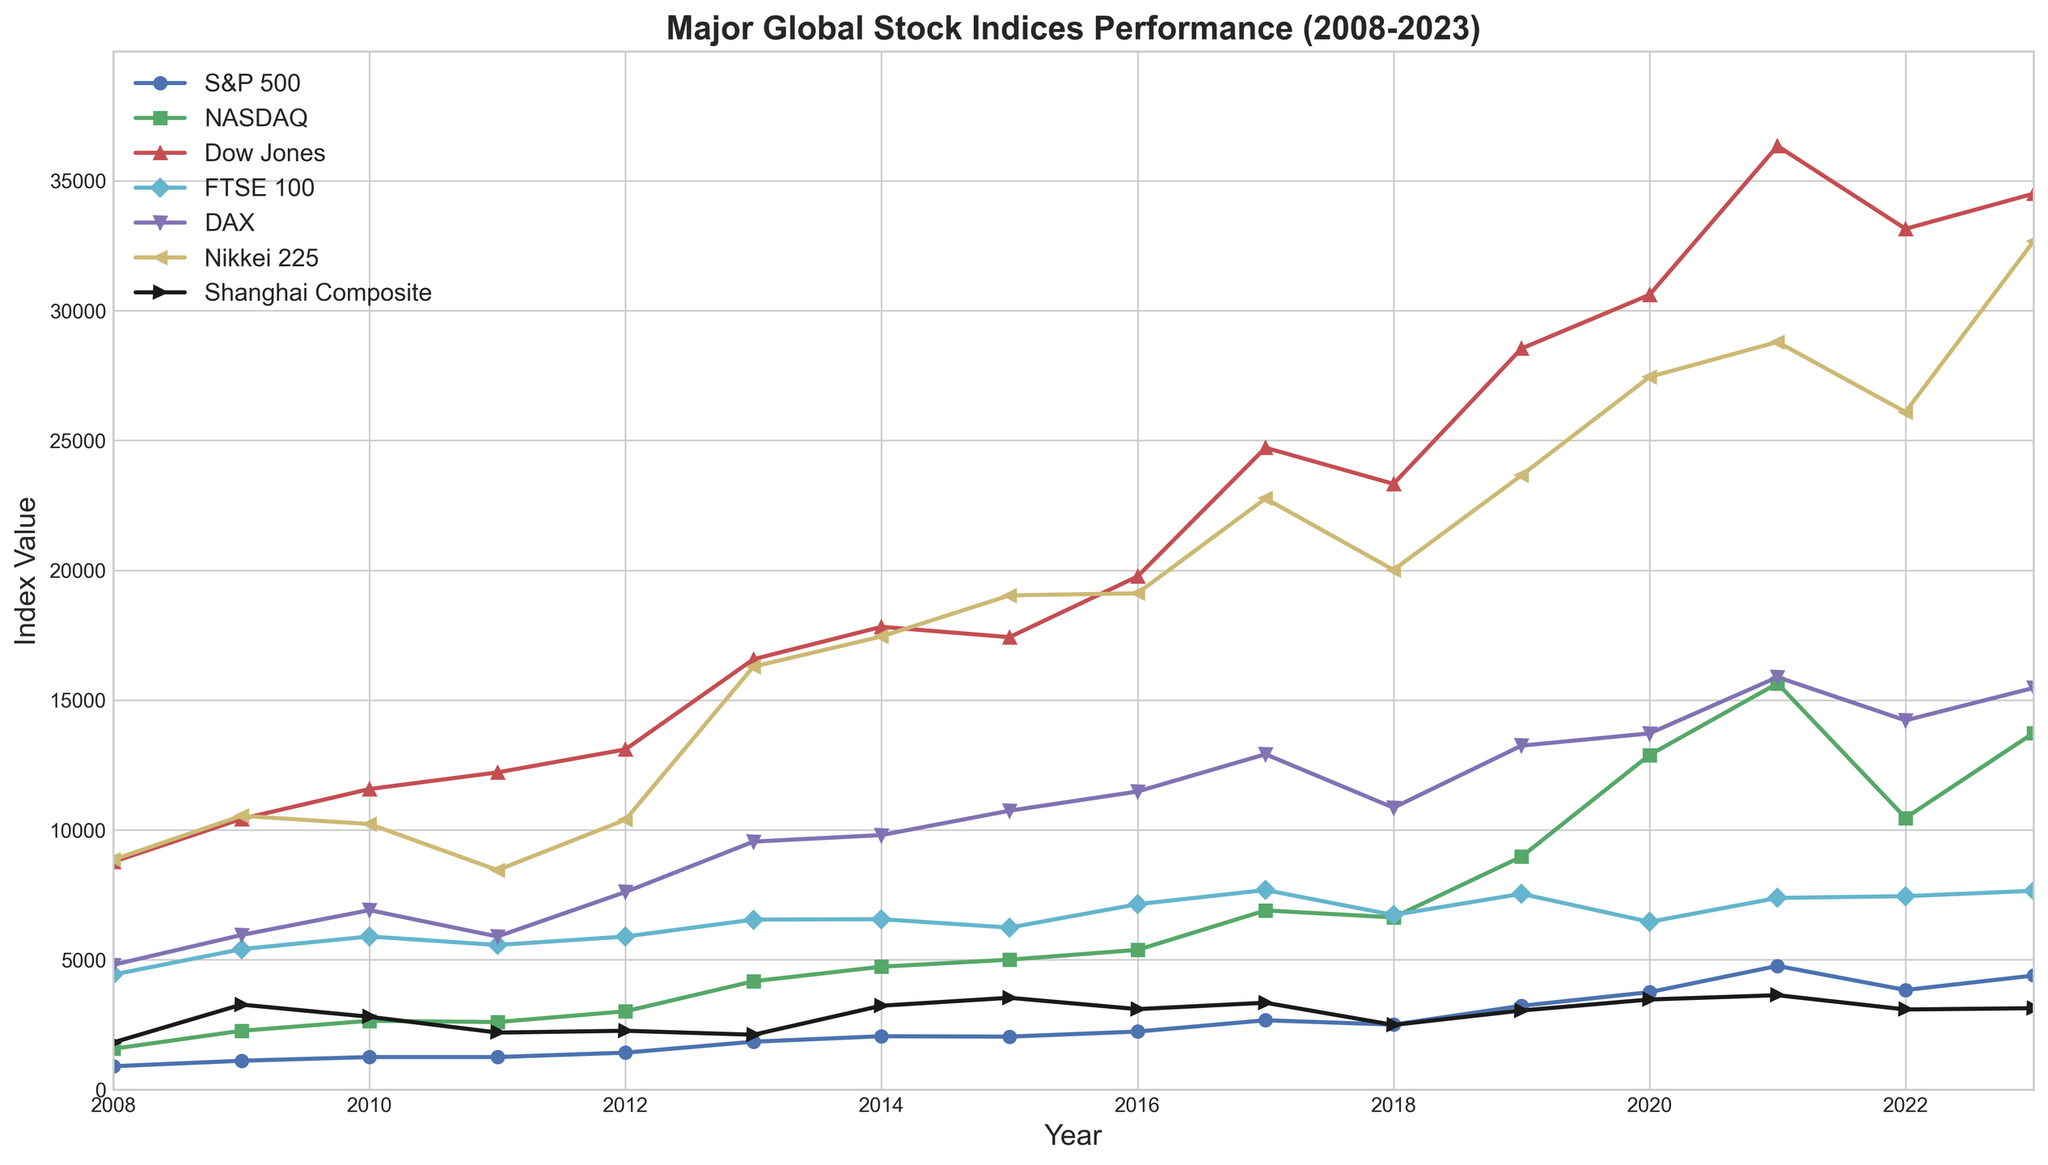What is the general trend of the S&P 500 index from 2008 to 2023? To identify the trend of the S&P 500 index, observe its values over the years. Starting from 903.25 in 2008, it increases to 4394.95 in 2023. There are fluctuations, but the overall direction is upward.
Answer: Upward Which index had the highest closing value in 2023? Look for the highest value among all indices for the year 2023. The Dow Jones has the highest closing value at 34501.11.
Answer: Dow Jones How did the NASDAQ perform in comparison to the S&P 500 in 2020? Compare the values for NASDAQ (12888.28) and S&P 500 (3756.07) for the year 2020. The NASDAQ is higher than the S&P 500 in 2020.
Answer: NASDAQ outperformed In which year did the Shanghai Composite reach its peak value according to the data? Locate the highest value for the Shanghai Composite index across all years. The peak value is 3639.78 in 2021.
Answer: 2021 How many years show a decrease in the FTSE 100 index from the previous year? Identify years where the FTSE 100 index value is less than the previous year. This occurs in 2011, 2014, 2015, 2018, and 2020.
Answer: 5 years What is the difference in the value of the DAX index between 2008 and 2023? Subtract the value in 2008 (4810.20) from the value in 2023 (15470.76). 15470.76 - 4810.20 = 10660.56
Answer: 10660.56 Among the major indices listed, which one had the smallest fluctuation between 2008 and 2023? Compute the fluctuation for each index by finding the difference between the maximum and minimum values. The Shanghai Composite fluctuates between 1820.81 (2008) and 3639.78 (2021), with the smallest range of 1818.97.
Answer: Shanghai Composite Which indices showed a decrease in value from 2021 to 2022? Compare the values of indices between 2021 and 2022. The S&P 500 (4766.18 to 3839.50), NASDAQ (15644.97 to 10466.48), DAX (15885.57 to 14221.10), and Nikkei 225 (28791.71 to 26094.68) showed a decrease.
Answer: S&P 500, NASDAQ, DAX, Nikkei 225 Which had a higher percentage increase from 2008 to 2023, the Dow Jones or the FTSE 100? Calculate the percentage increase for both indices. For Dow Jones: ((34501.11 - 8776.39) / 8776.39) * 100 = 293.09%. For FTSE 100: ((7659.13 - 4434.17) / 4434.17) * 100 = 72.77%. The Dow Jones had a higher percentage increase.
Answer: Dow Jones 